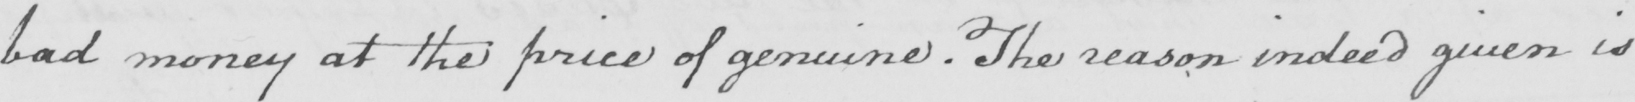What is written in this line of handwriting? bad money at the price of genuine . The reason indeed given is 